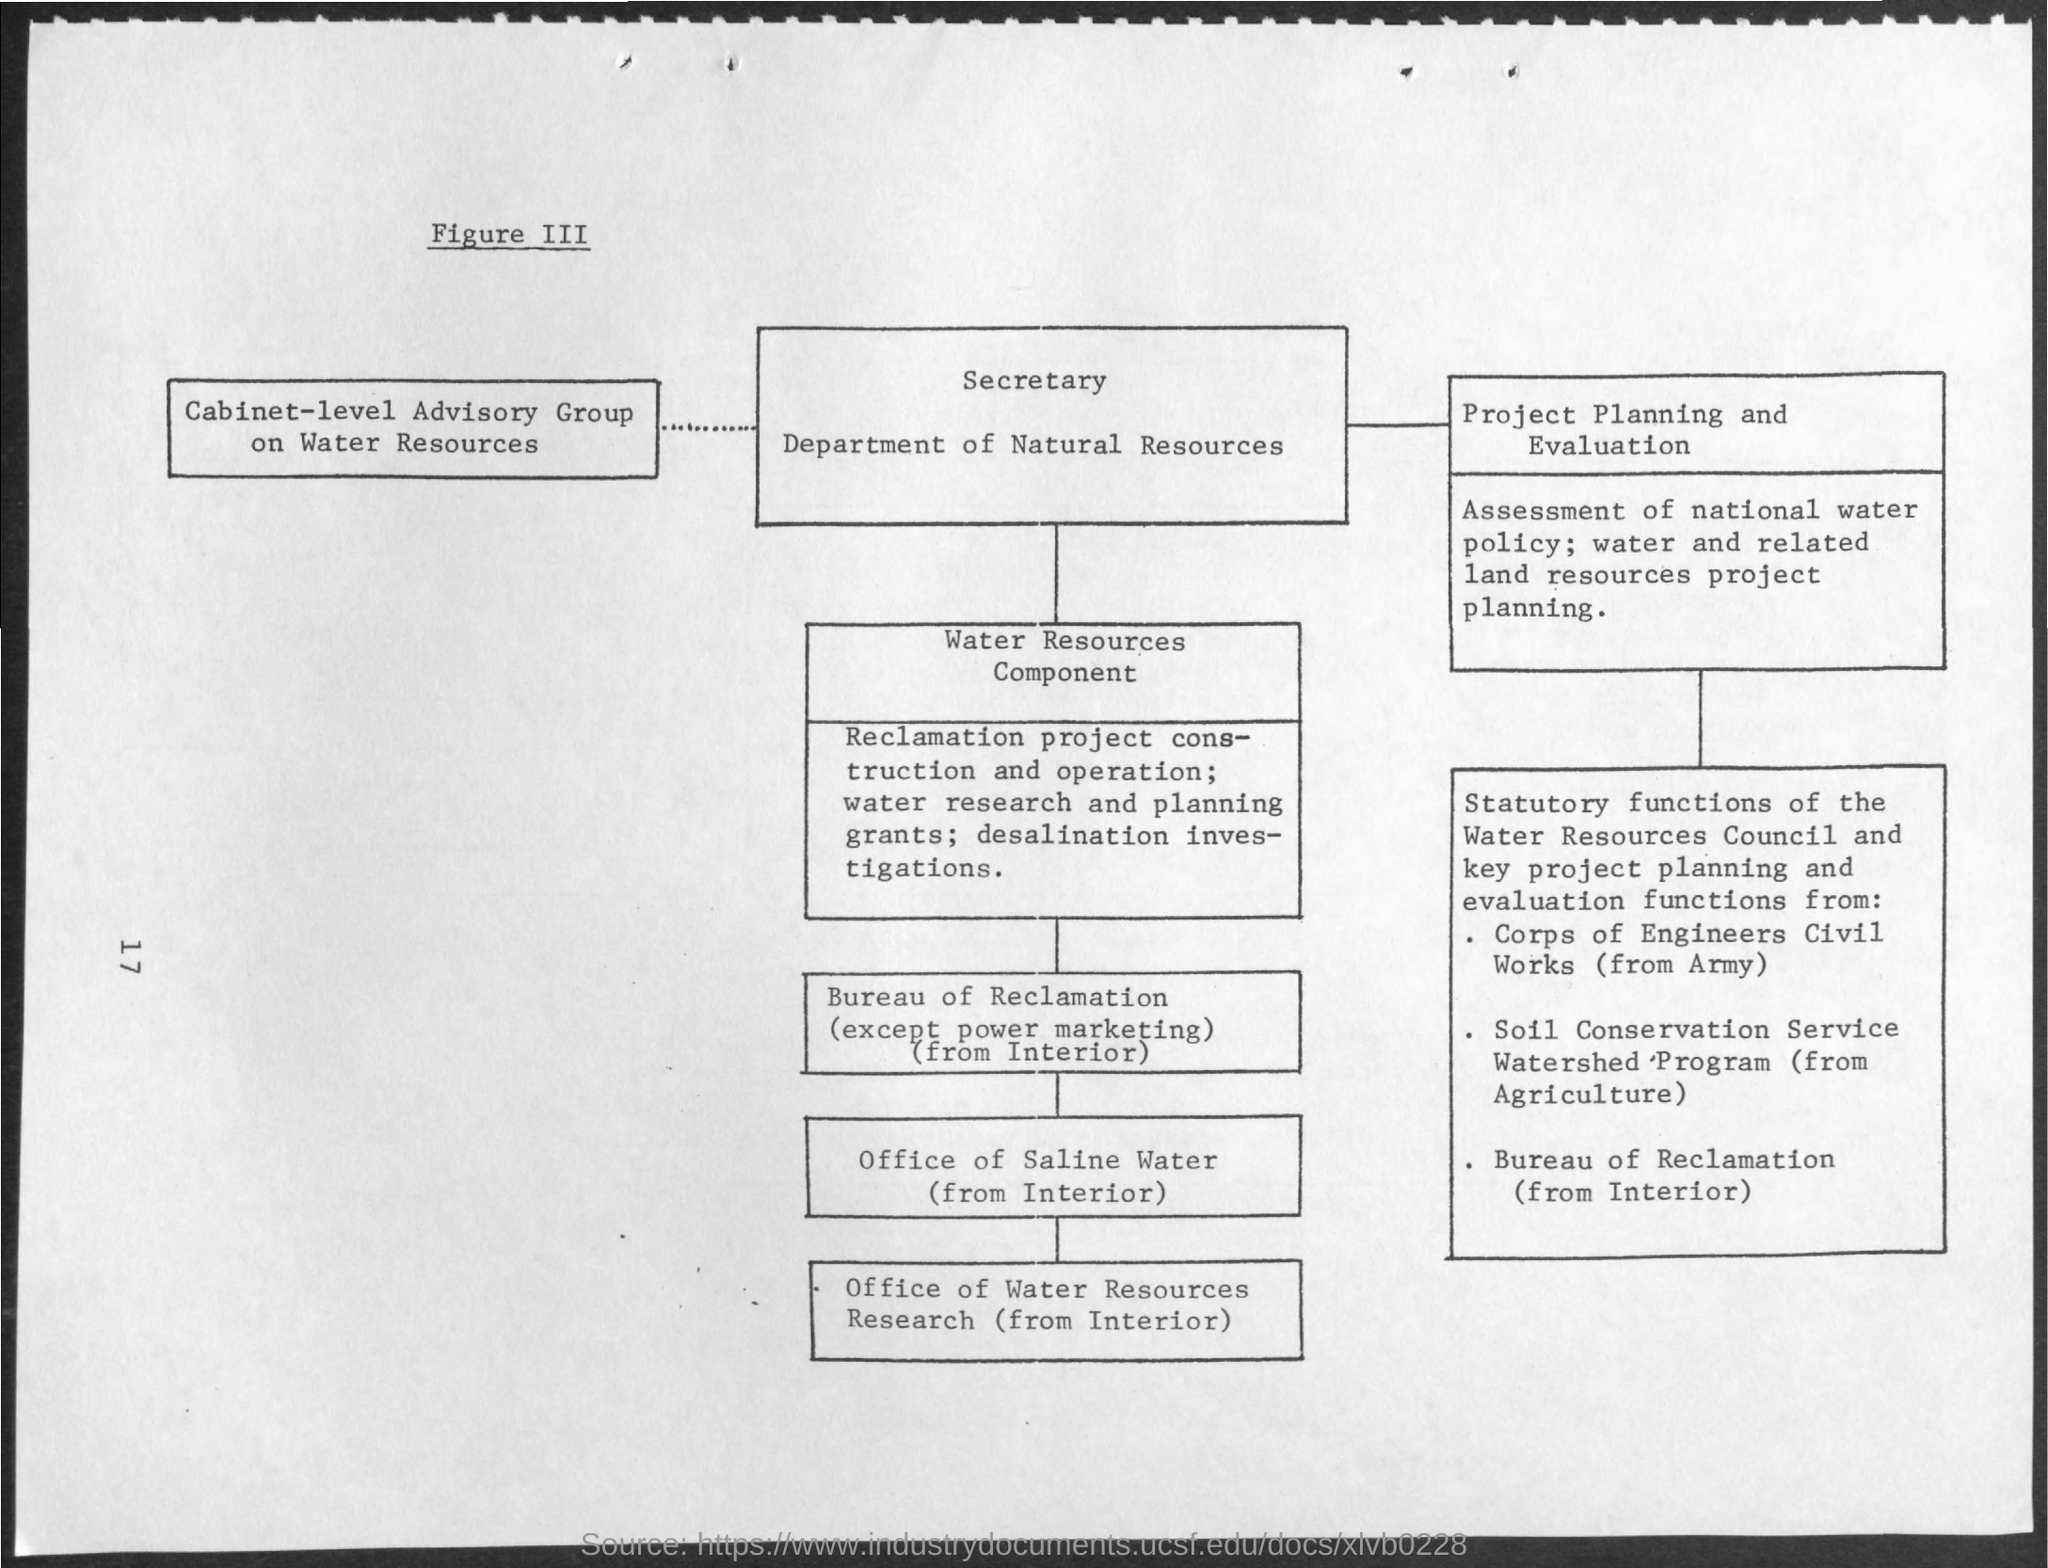Mention a couple of crucial points in this snapshot. The figure number is iii.. The page number is 17. 